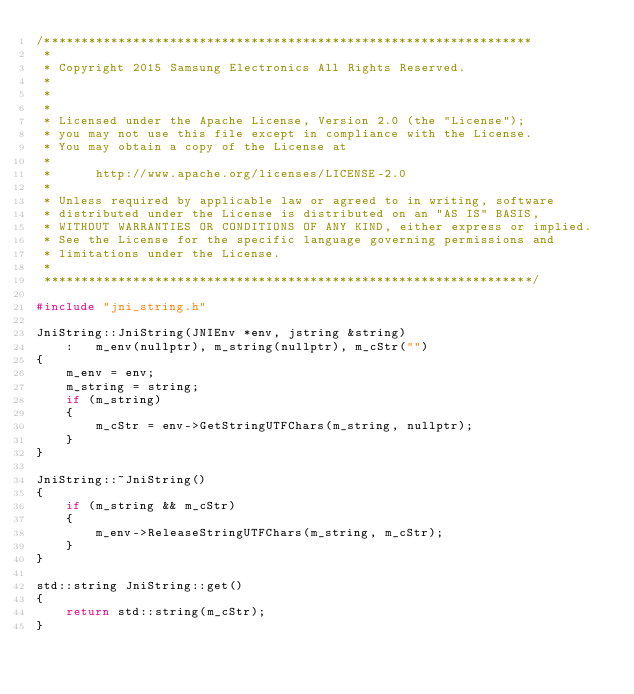Convert code to text. <code><loc_0><loc_0><loc_500><loc_500><_C++_>/******************************************************************
 *
 * Copyright 2015 Samsung Electronics All Rights Reserved.
 *
 *
 *
 * Licensed under the Apache License, Version 2.0 (the "License");
 * you may not use this file except in compliance with the License.
 * You may obtain a copy of the License at
 *
 *      http://www.apache.org/licenses/LICENSE-2.0
 *
 * Unless required by applicable law or agreed to in writing, software
 * distributed under the License is distributed on an "AS IS" BASIS,
 * WITHOUT WARRANTIES OR CONDITIONS OF ANY KIND, either express or implied.
 * See the License for the specific language governing permissions and
 * limitations under the License.
 *
 ******************************************************************/

#include "jni_string.h"

JniString::JniString(JNIEnv *env, jstring &string)
    :   m_env(nullptr), m_string(nullptr), m_cStr("")
{
    m_env = env;
    m_string = string;
    if (m_string)
    {
        m_cStr = env->GetStringUTFChars(m_string, nullptr);
    }
}

JniString::~JniString()
{
    if (m_string && m_cStr)
    {
        m_env->ReleaseStringUTFChars(m_string, m_cStr);
    }
}

std::string JniString::get()
{
    return std::string(m_cStr);
}
</code> 